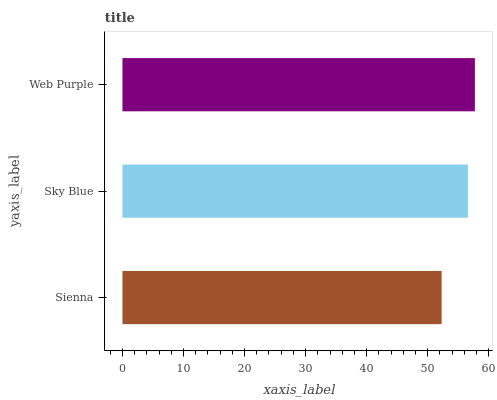Is Sienna the minimum?
Answer yes or no. Yes. Is Web Purple the maximum?
Answer yes or no. Yes. Is Sky Blue the minimum?
Answer yes or no. No. Is Sky Blue the maximum?
Answer yes or no. No. Is Sky Blue greater than Sienna?
Answer yes or no. Yes. Is Sienna less than Sky Blue?
Answer yes or no. Yes. Is Sienna greater than Sky Blue?
Answer yes or no. No. Is Sky Blue less than Sienna?
Answer yes or no. No. Is Sky Blue the high median?
Answer yes or no. Yes. Is Sky Blue the low median?
Answer yes or no. Yes. Is Web Purple the high median?
Answer yes or no. No. Is Sienna the low median?
Answer yes or no. No. 